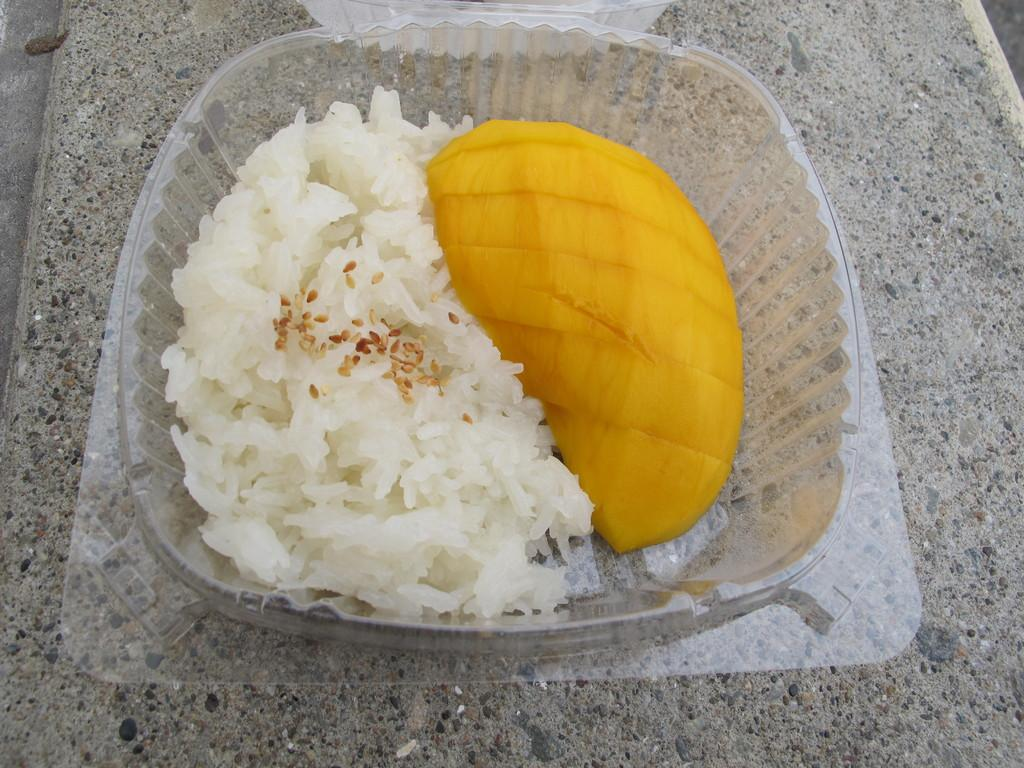What is the main structure in the image? There is a platform in the image. What is placed on the platform? There is a box on the platform. What is inside the box? The box contains food. How is the box connected to the platform using a chain in the image? There is no chain connecting the box to the platform in the image. 